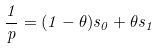Convert formula to latex. <formula><loc_0><loc_0><loc_500><loc_500>\frac { 1 } { p } = ( 1 - \theta ) s _ { 0 } + \theta s _ { 1 }</formula> 